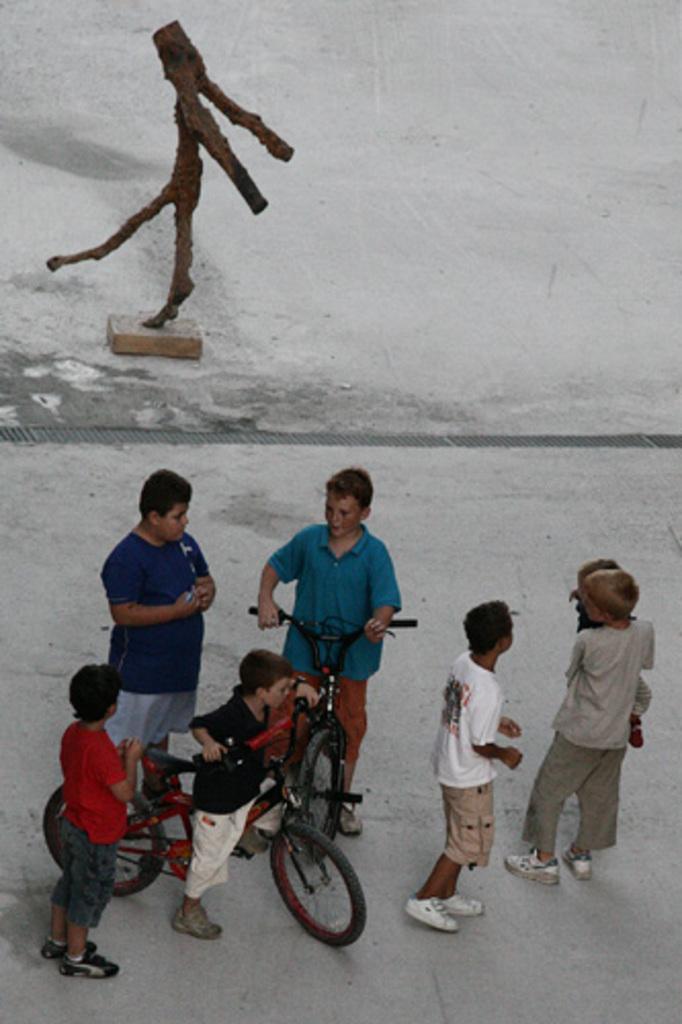Can you describe this image briefly? In the middle there is a boy he is riding bicycle ,he wear blue t shirt and trouser. On the right there is a boy he wear gray t shirt ,trouser and shoes. On the left there is a boy he wear red t shirt , trouser and shoes. 